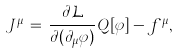Convert formula to latex. <formula><loc_0><loc_0><loc_500><loc_500>J ^ { \mu } \, = \, { \frac { \partial { \mathcal { L } } } { \partial ( \partial _ { \mu } \varphi ) } } Q [ \varphi ] - f ^ { \mu } ,</formula> 